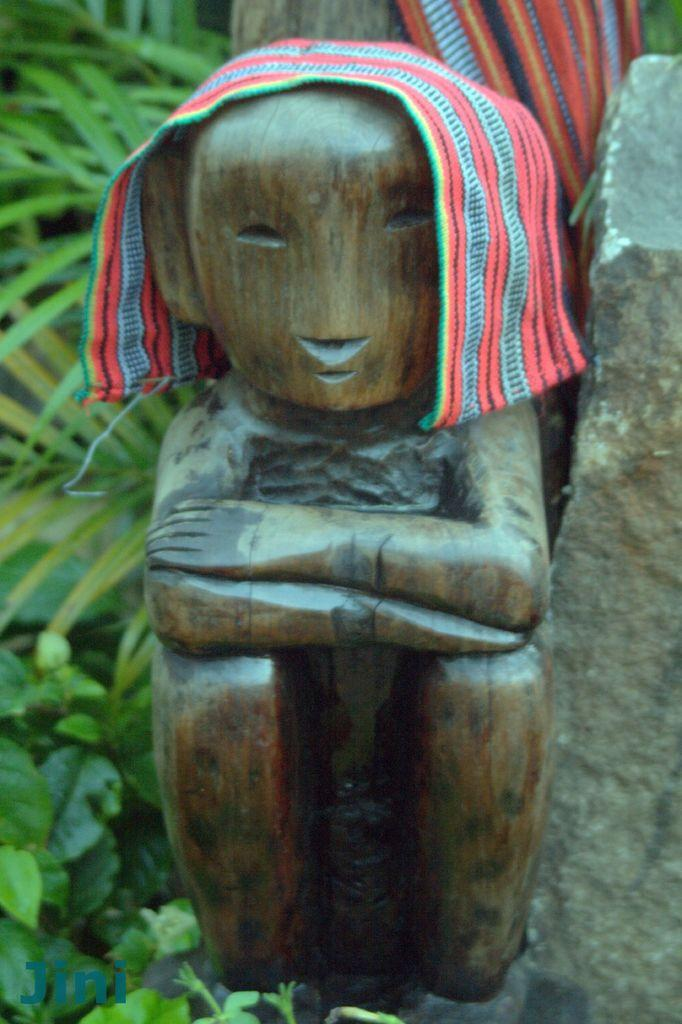What is covering the sculpture in the middle of the image? There is a cloth on a sculpture in the middle of the image. What can be seen in the background of the image? There are plants in the background of the image. What is located on the right side of the image? There is a rock on the right side of the image. What type of blood is visible on the doll in the image? There is no doll or blood present in the image. How many potatoes can be seen in the image? There are no potatoes present in the image. 